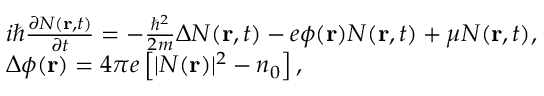<formula> <loc_0><loc_0><loc_500><loc_500>\begin{array} { r l } & { i \hbar { } { \partial N ( { r } , t ) } } { \partial t } = - \frac { { { \hbar { ^ } { 2 } } } } { 2 m } \Delta N ( { r } , t ) - e \phi ( { r } ) N ( { r } , t ) + \mu N ( { r } , t ) , } \\ & { \Delta \phi ( { r } ) = 4 \pi e \left [ { | N ( { r } ) { | ^ { 2 } } - { n _ { 0 } } } \right ] , } \end{array}</formula> 